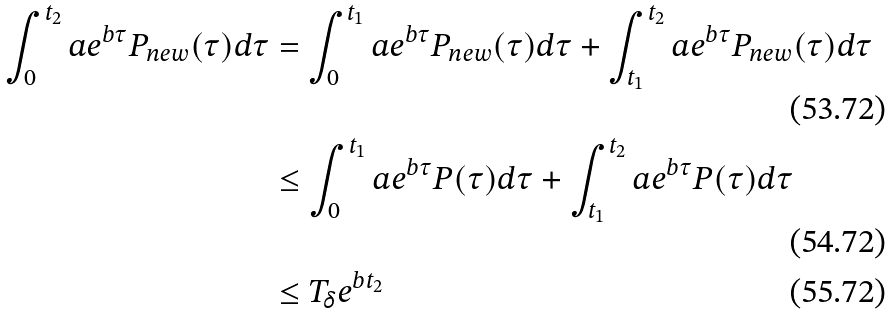Convert formula to latex. <formula><loc_0><loc_0><loc_500><loc_500>\int _ { 0 } ^ { t _ { 2 } } a e ^ { b \tau } P _ { n e w } ( \tau ) d \tau & = \int _ { 0 } ^ { t _ { 1 } } a e ^ { b \tau } P _ { n e w } ( \tau ) d \tau + \int _ { t _ { 1 } } ^ { t _ { 2 } } a e ^ { b \tau } P _ { n e w } ( \tau ) d \tau \\ & \leq \int _ { 0 } ^ { t _ { 1 } } a e ^ { b \tau } P ( \tau ) d \tau + \int _ { t _ { 1 } } ^ { t _ { 2 } } a e ^ { b \tau } P ( \tau ) d \tau \\ & \leq T _ { \delta } e ^ { b t _ { 2 } }</formula> 